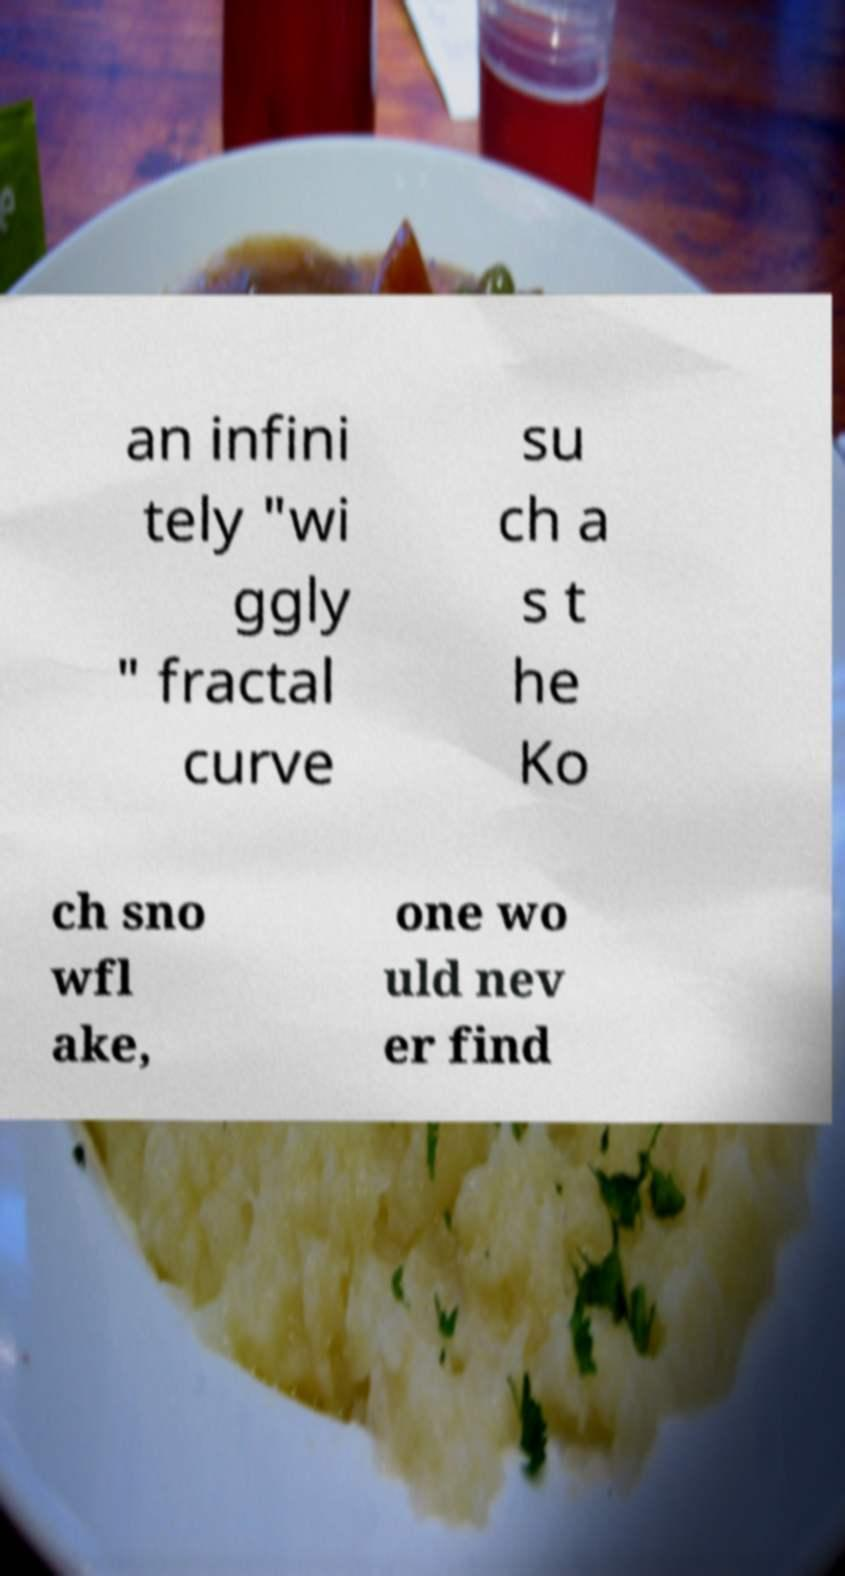Please identify and transcribe the text found in this image. an infini tely "wi ggly " fractal curve su ch a s t he Ko ch sno wfl ake, one wo uld nev er find 